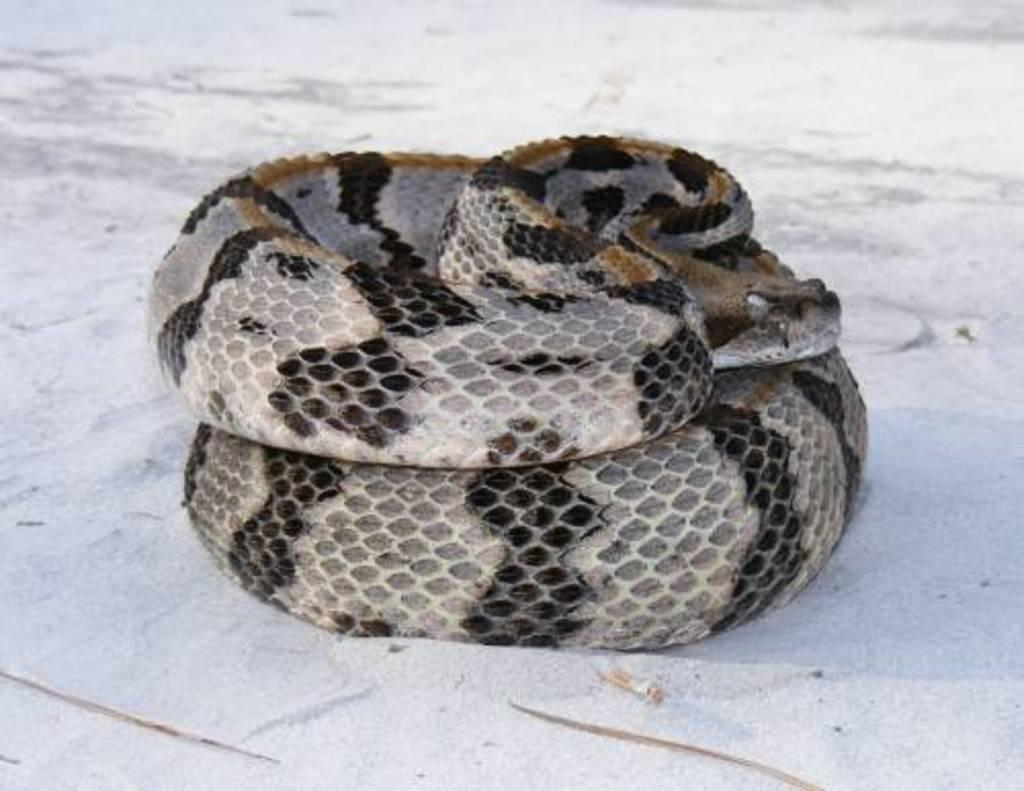What color is the ground in the image? The ground in the image is white. What animal can be seen in the image? There is a snake in the image. What colors make up the snake's appearance? The snake is white, black, and brown in color. How does the snake's sister feel about its growth in the image? There is no mention of a snake's sister or growth in the image, so it is not possible to answer that question. 